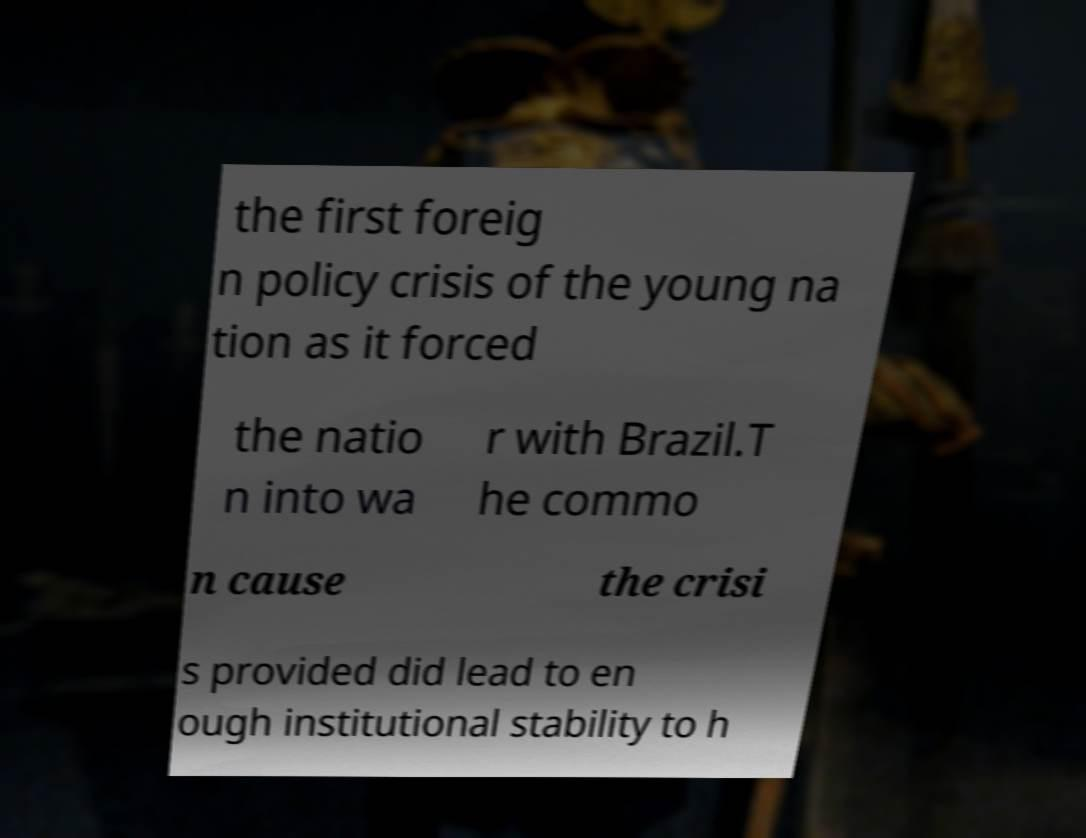Please identify and transcribe the text found in this image. the first foreig n policy crisis of the young na tion as it forced the natio n into wa r with Brazil.T he commo n cause the crisi s provided did lead to en ough institutional stability to h 